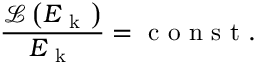<formula> <loc_0><loc_0><loc_500><loc_500>\frac { \mathcal { L } \left ( E _ { k } \right ) } { E _ { k } } = c o n s t .</formula> 